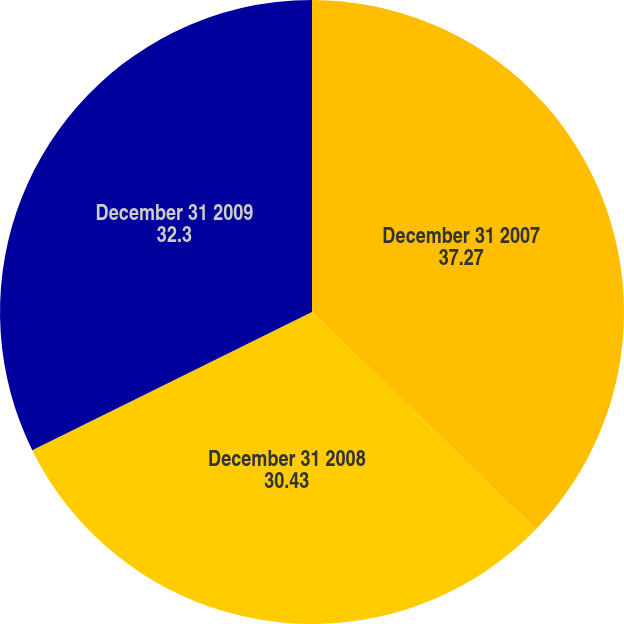<chart> <loc_0><loc_0><loc_500><loc_500><pie_chart><fcel>December 31 2007<fcel>December 31 2008<fcel>December 31 2009<nl><fcel>37.27%<fcel>30.43%<fcel>32.3%<nl></chart> 